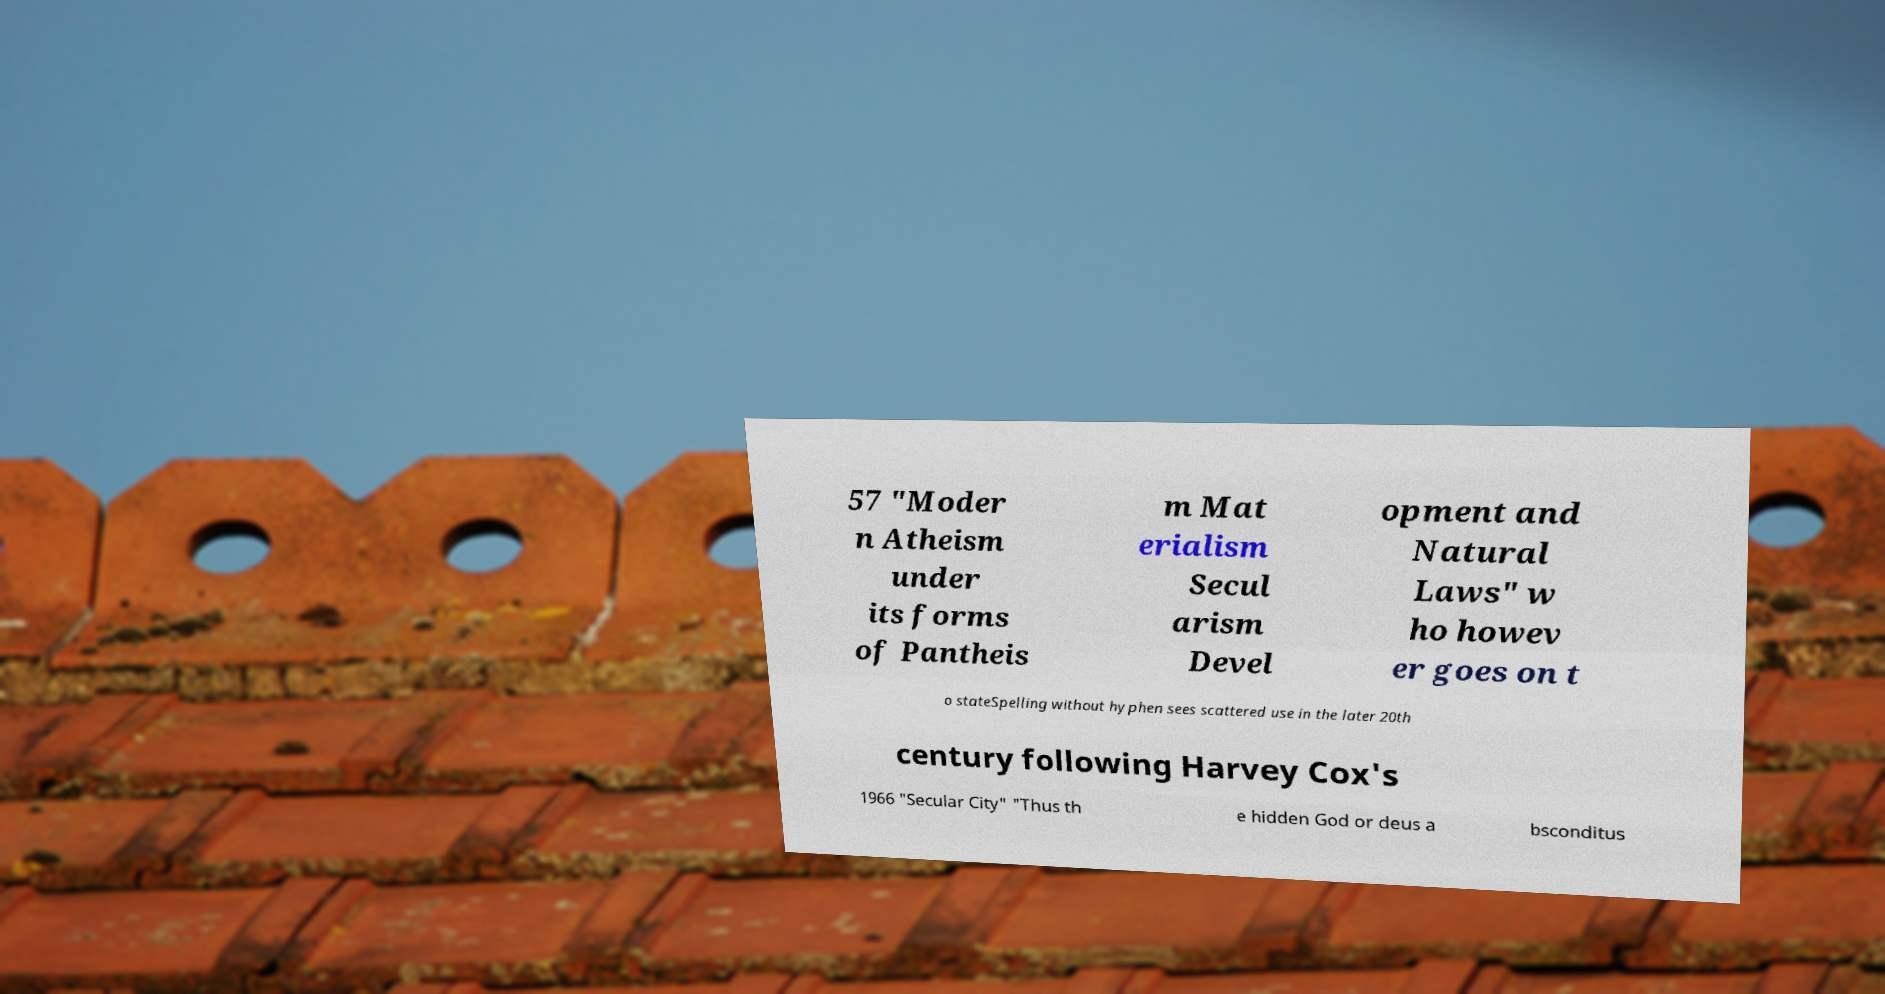There's text embedded in this image that I need extracted. Can you transcribe it verbatim? 57 "Moder n Atheism under its forms of Pantheis m Mat erialism Secul arism Devel opment and Natural Laws" w ho howev er goes on t o stateSpelling without hyphen sees scattered use in the later 20th century following Harvey Cox's 1966 "Secular City" "Thus th e hidden God or deus a bsconditus 